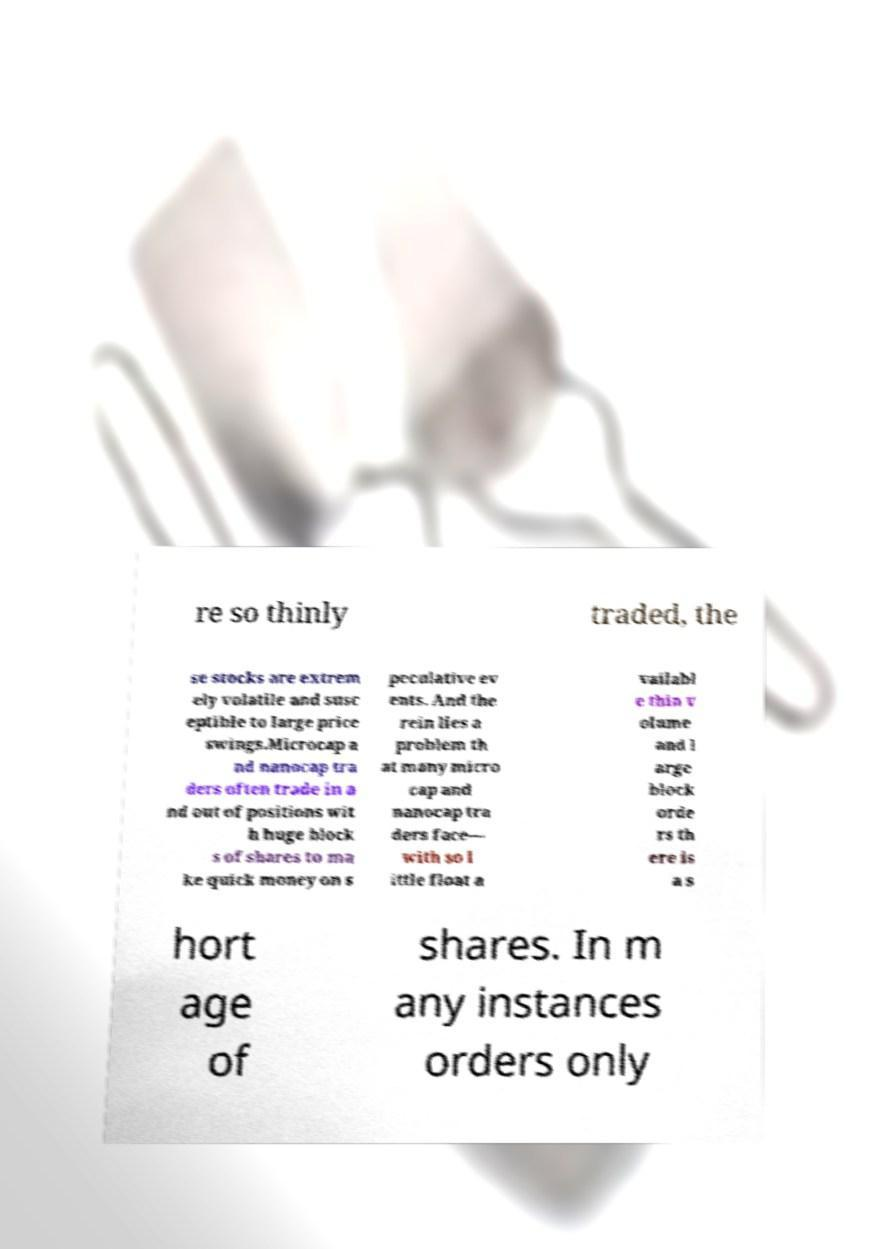There's text embedded in this image that I need extracted. Can you transcribe it verbatim? re so thinly traded, the se stocks are extrem ely volatile and susc eptible to large price swings.Microcap a nd nanocap tra ders often trade in a nd out of positions wit h huge block s of shares to ma ke quick money on s peculative ev ents. And the rein lies a problem th at many micro cap and nanocap tra ders face— with so l ittle float a vailabl e thin v olume and l arge block orde rs th ere is a s hort age of shares. In m any instances orders only 